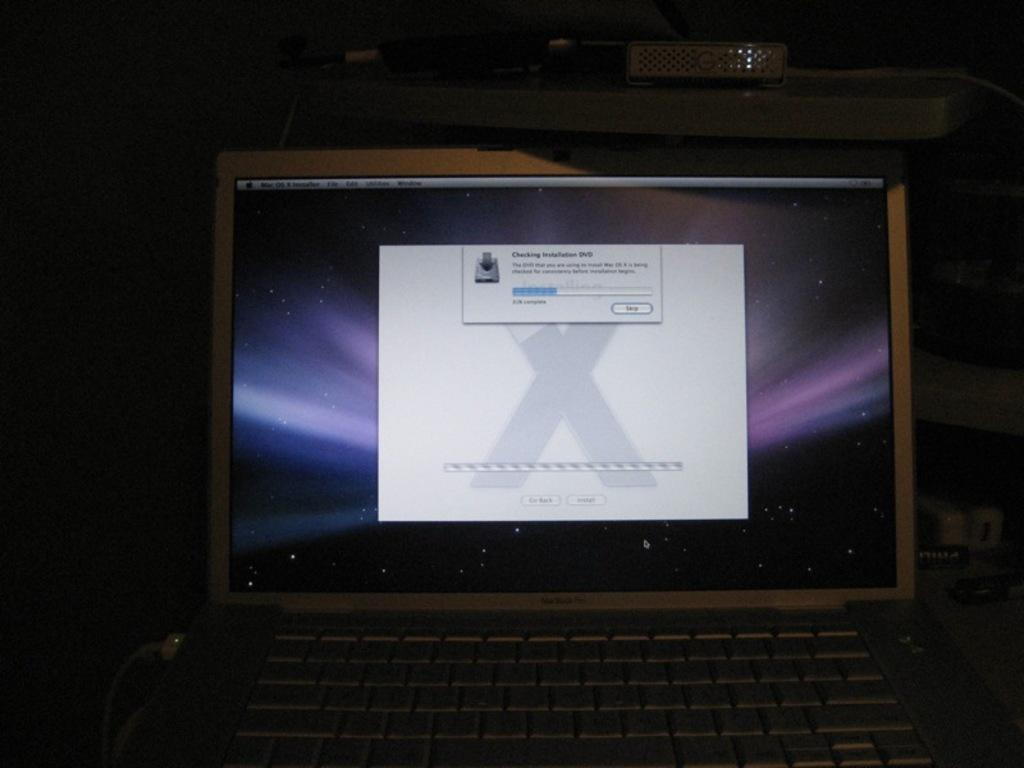<image>
Share a concise interpretation of the image provided. an open macbook with words on the screen that say 'checking installation dvd' 